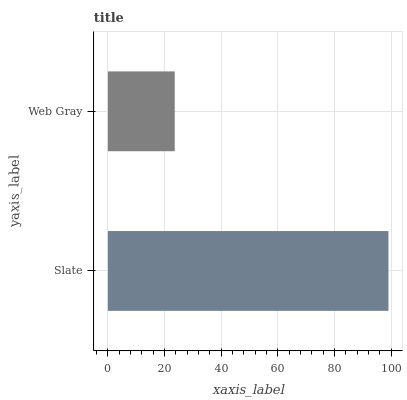Is Web Gray the minimum?
Answer yes or no. Yes. Is Slate the maximum?
Answer yes or no. Yes. Is Web Gray the maximum?
Answer yes or no. No. Is Slate greater than Web Gray?
Answer yes or no. Yes. Is Web Gray less than Slate?
Answer yes or no. Yes. Is Web Gray greater than Slate?
Answer yes or no. No. Is Slate less than Web Gray?
Answer yes or no. No. Is Slate the high median?
Answer yes or no. Yes. Is Web Gray the low median?
Answer yes or no. Yes. Is Web Gray the high median?
Answer yes or no. No. Is Slate the low median?
Answer yes or no. No. 